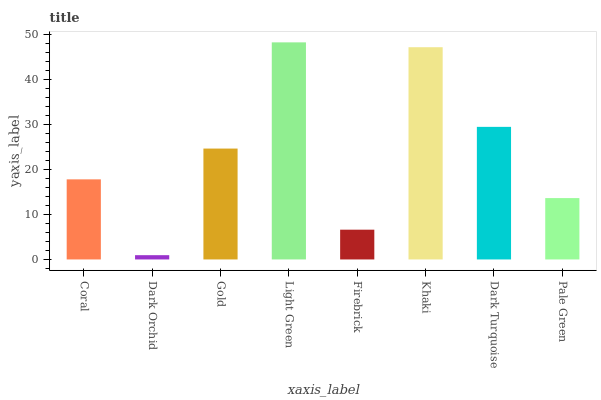Is Dark Orchid the minimum?
Answer yes or no. Yes. Is Light Green the maximum?
Answer yes or no. Yes. Is Gold the minimum?
Answer yes or no. No. Is Gold the maximum?
Answer yes or no. No. Is Gold greater than Dark Orchid?
Answer yes or no. Yes. Is Dark Orchid less than Gold?
Answer yes or no. Yes. Is Dark Orchid greater than Gold?
Answer yes or no. No. Is Gold less than Dark Orchid?
Answer yes or no. No. Is Gold the high median?
Answer yes or no. Yes. Is Coral the low median?
Answer yes or no. Yes. Is Pale Green the high median?
Answer yes or no. No. Is Firebrick the low median?
Answer yes or no. No. 